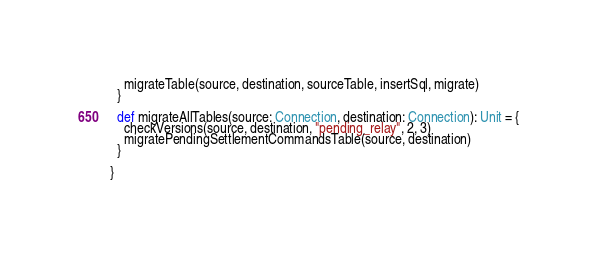<code> <loc_0><loc_0><loc_500><loc_500><_Scala_>    migrateTable(source, destination, sourceTable, insertSql, migrate)
  }

  def migrateAllTables(source: Connection, destination: Connection): Unit = {
    checkVersions(source, destination, "pending_relay", 2, 3)
    migratePendingSettlementCommandsTable(source, destination)
  }

}
</code> 